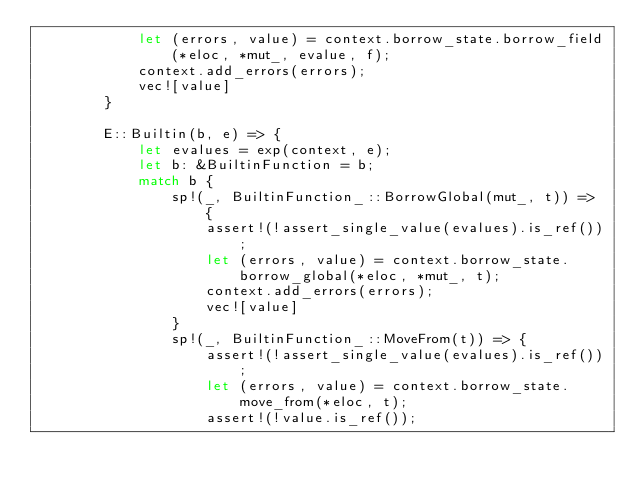Convert code to text. <code><loc_0><loc_0><loc_500><loc_500><_Rust_>            let (errors, value) = context.borrow_state.borrow_field(*eloc, *mut_, evalue, f);
            context.add_errors(errors);
            vec![value]
        }

        E::Builtin(b, e) => {
            let evalues = exp(context, e);
            let b: &BuiltinFunction = b;
            match b {
                sp!(_, BuiltinFunction_::BorrowGlobal(mut_, t)) => {
                    assert!(!assert_single_value(evalues).is_ref());
                    let (errors, value) = context.borrow_state.borrow_global(*eloc, *mut_, t);
                    context.add_errors(errors);
                    vec![value]
                }
                sp!(_, BuiltinFunction_::MoveFrom(t)) => {
                    assert!(!assert_single_value(evalues).is_ref());
                    let (errors, value) = context.borrow_state.move_from(*eloc, t);
                    assert!(!value.is_ref());</code> 